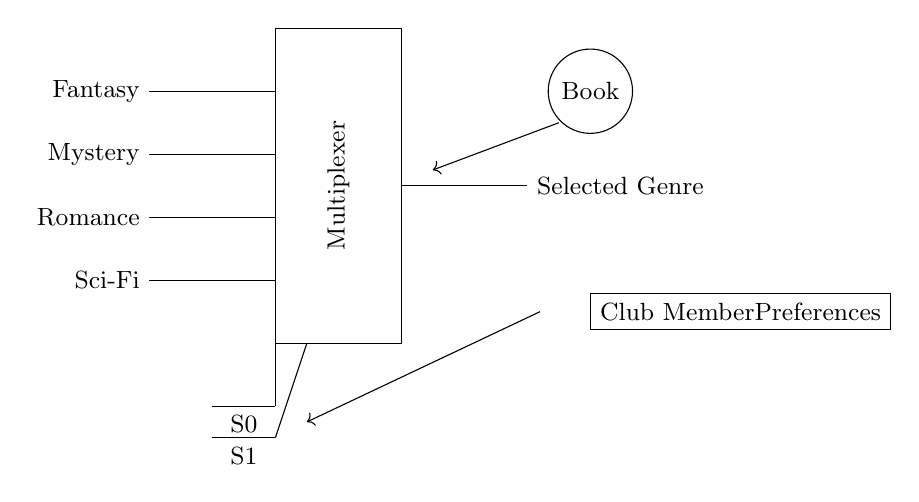What are the input genres for the multiplexer? The input genres listed are Fantasy, Mystery, Romance, and Sci-Fi, which are the labels connected to the input lines of the multiplexer.
Answer: Fantasy, Mystery, Romance, Sci-Fi How many select lines does the multiplexer have? The diagram shows two select lines denoted as S0 and S1, which are used to select which input will be passed to the output.
Answer: 2 What is the output of the multiplexer based on member preferences? The output connected to the selected genre will reflect the choice made through the select lines based on club member preferences. It represents the selected book genre.
Answer: Selected Genre Which component is responsible for selecting the book genre? The multiplexer in the circuit is the component that functions to select one out of the multiple input genres based on select lines.
Answer: Multiplexer If S0 is 0 and S1 is 1, which input will the multiplexer select? In a standard two-input multiplexer, the select line combination of S0 being 0 and S1 being 1 typically selects the input at the second position from the top, which corresponds to Mystery.
Answer: Mystery Why is the output labeled as "Selected Genre"? This label indicates that the output of the multiplexer will display the genre chosen according to the preferences of the club members, effectively summarizing the multiplexer’s function in the context.
Answer: Selected Genre 